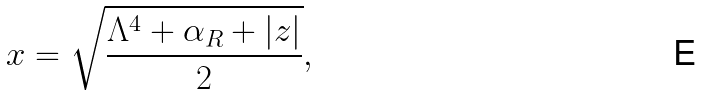Convert formula to latex. <formula><loc_0><loc_0><loc_500><loc_500>x = \sqrt { \frac { \Lambda ^ { 4 } + \alpha _ { R } + | z | } { 2 } } ,</formula> 